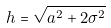Convert formula to latex. <formula><loc_0><loc_0><loc_500><loc_500>h = \sqrt { a ^ { 2 } + 2 \sigma ^ { 2 } }</formula> 